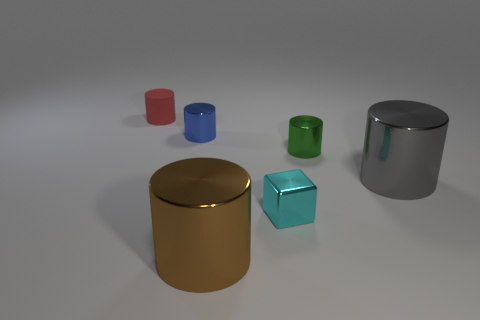Do the tiny blue shiny object and the brown thing have the same shape?
Provide a succinct answer. Yes. What number of small objects are brown things or green matte cylinders?
Give a very brief answer. 0. The small rubber cylinder has what color?
Give a very brief answer. Red. What is the shape of the big metal object to the left of the big thing right of the cyan shiny object?
Give a very brief answer. Cylinder. Is there a brown object made of the same material as the cube?
Your answer should be very brief. Yes. There is a shiny object that is behind the green cylinder; is its size the same as the tiny green cylinder?
Your response must be concise. Yes. What number of purple things are either metal balls or small objects?
Provide a short and direct response. 0. There is a big object that is to the right of the small green metallic cylinder; what is its material?
Make the answer very short. Metal. What number of green metallic cylinders are in front of the big metal cylinder that is right of the green metallic thing?
Provide a succinct answer. 0. What number of other matte objects have the same shape as the cyan thing?
Your answer should be compact. 0. 